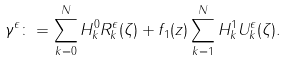Convert formula to latex. <formula><loc_0><loc_0><loc_500><loc_500>\gamma ^ { \epsilon } \colon = \sum _ { k = 0 } ^ { N } H ^ { 0 } _ { k } R ^ { \epsilon } _ { k } ( \zeta ) + f _ { 1 } ( z ) \sum _ { k = 1 } ^ { N } H ^ { 1 } _ { k } U ^ { \epsilon } _ { k } ( \zeta ) .</formula> 